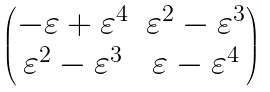<formula> <loc_0><loc_0><loc_500><loc_500>\begin{pmatrix} - \varepsilon + \varepsilon ^ { 4 } & \varepsilon ^ { 2 } - \varepsilon ^ { 3 } \\ \varepsilon ^ { 2 } - \varepsilon ^ { 3 } & \varepsilon - \varepsilon ^ { 4 } \end{pmatrix}</formula> 